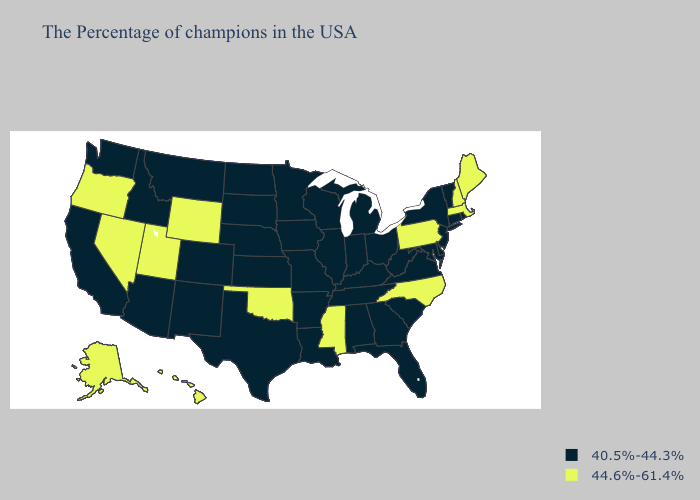What is the highest value in the USA?
Short answer required. 44.6%-61.4%. Does Kansas have the same value as Wyoming?
Write a very short answer. No. Does Michigan have a lower value than Arizona?
Be succinct. No. What is the highest value in states that border Kentucky?
Write a very short answer. 40.5%-44.3%. Which states have the lowest value in the MidWest?
Quick response, please. Ohio, Michigan, Indiana, Wisconsin, Illinois, Missouri, Minnesota, Iowa, Kansas, Nebraska, South Dakota, North Dakota. Among the states that border Washington , which have the lowest value?
Short answer required. Idaho. Does North Carolina have a lower value than Delaware?
Quick response, please. No. Name the states that have a value in the range 44.6%-61.4%?
Keep it brief. Maine, Massachusetts, New Hampshire, Pennsylvania, North Carolina, Mississippi, Oklahoma, Wyoming, Utah, Nevada, Oregon, Alaska, Hawaii. Name the states that have a value in the range 44.6%-61.4%?
Be succinct. Maine, Massachusetts, New Hampshire, Pennsylvania, North Carolina, Mississippi, Oklahoma, Wyoming, Utah, Nevada, Oregon, Alaska, Hawaii. What is the highest value in the USA?
Concise answer only. 44.6%-61.4%. Does North Carolina have the lowest value in the USA?
Answer briefly. No. Which states have the lowest value in the Northeast?
Short answer required. Rhode Island, Vermont, Connecticut, New York, New Jersey. Name the states that have a value in the range 40.5%-44.3%?
Concise answer only. Rhode Island, Vermont, Connecticut, New York, New Jersey, Delaware, Maryland, Virginia, South Carolina, West Virginia, Ohio, Florida, Georgia, Michigan, Kentucky, Indiana, Alabama, Tennessee, Wisconsin, Illinois, Louisiana, Missouri, Arkansas, Minnesota, Iowa, Kansas, Nebraska, Texas, South Dakota, North Dakota, Colorado, New Mexico, Montana, Arizona, Idaho, California, Washington. What is the highest value in the West ?
Answer briefly. 44.6%-61.4%. Among the states that border Wisconsin , which have the lowest value?
Write a very short answer. Michigan, Illinois, Minnesota, Iowa. 